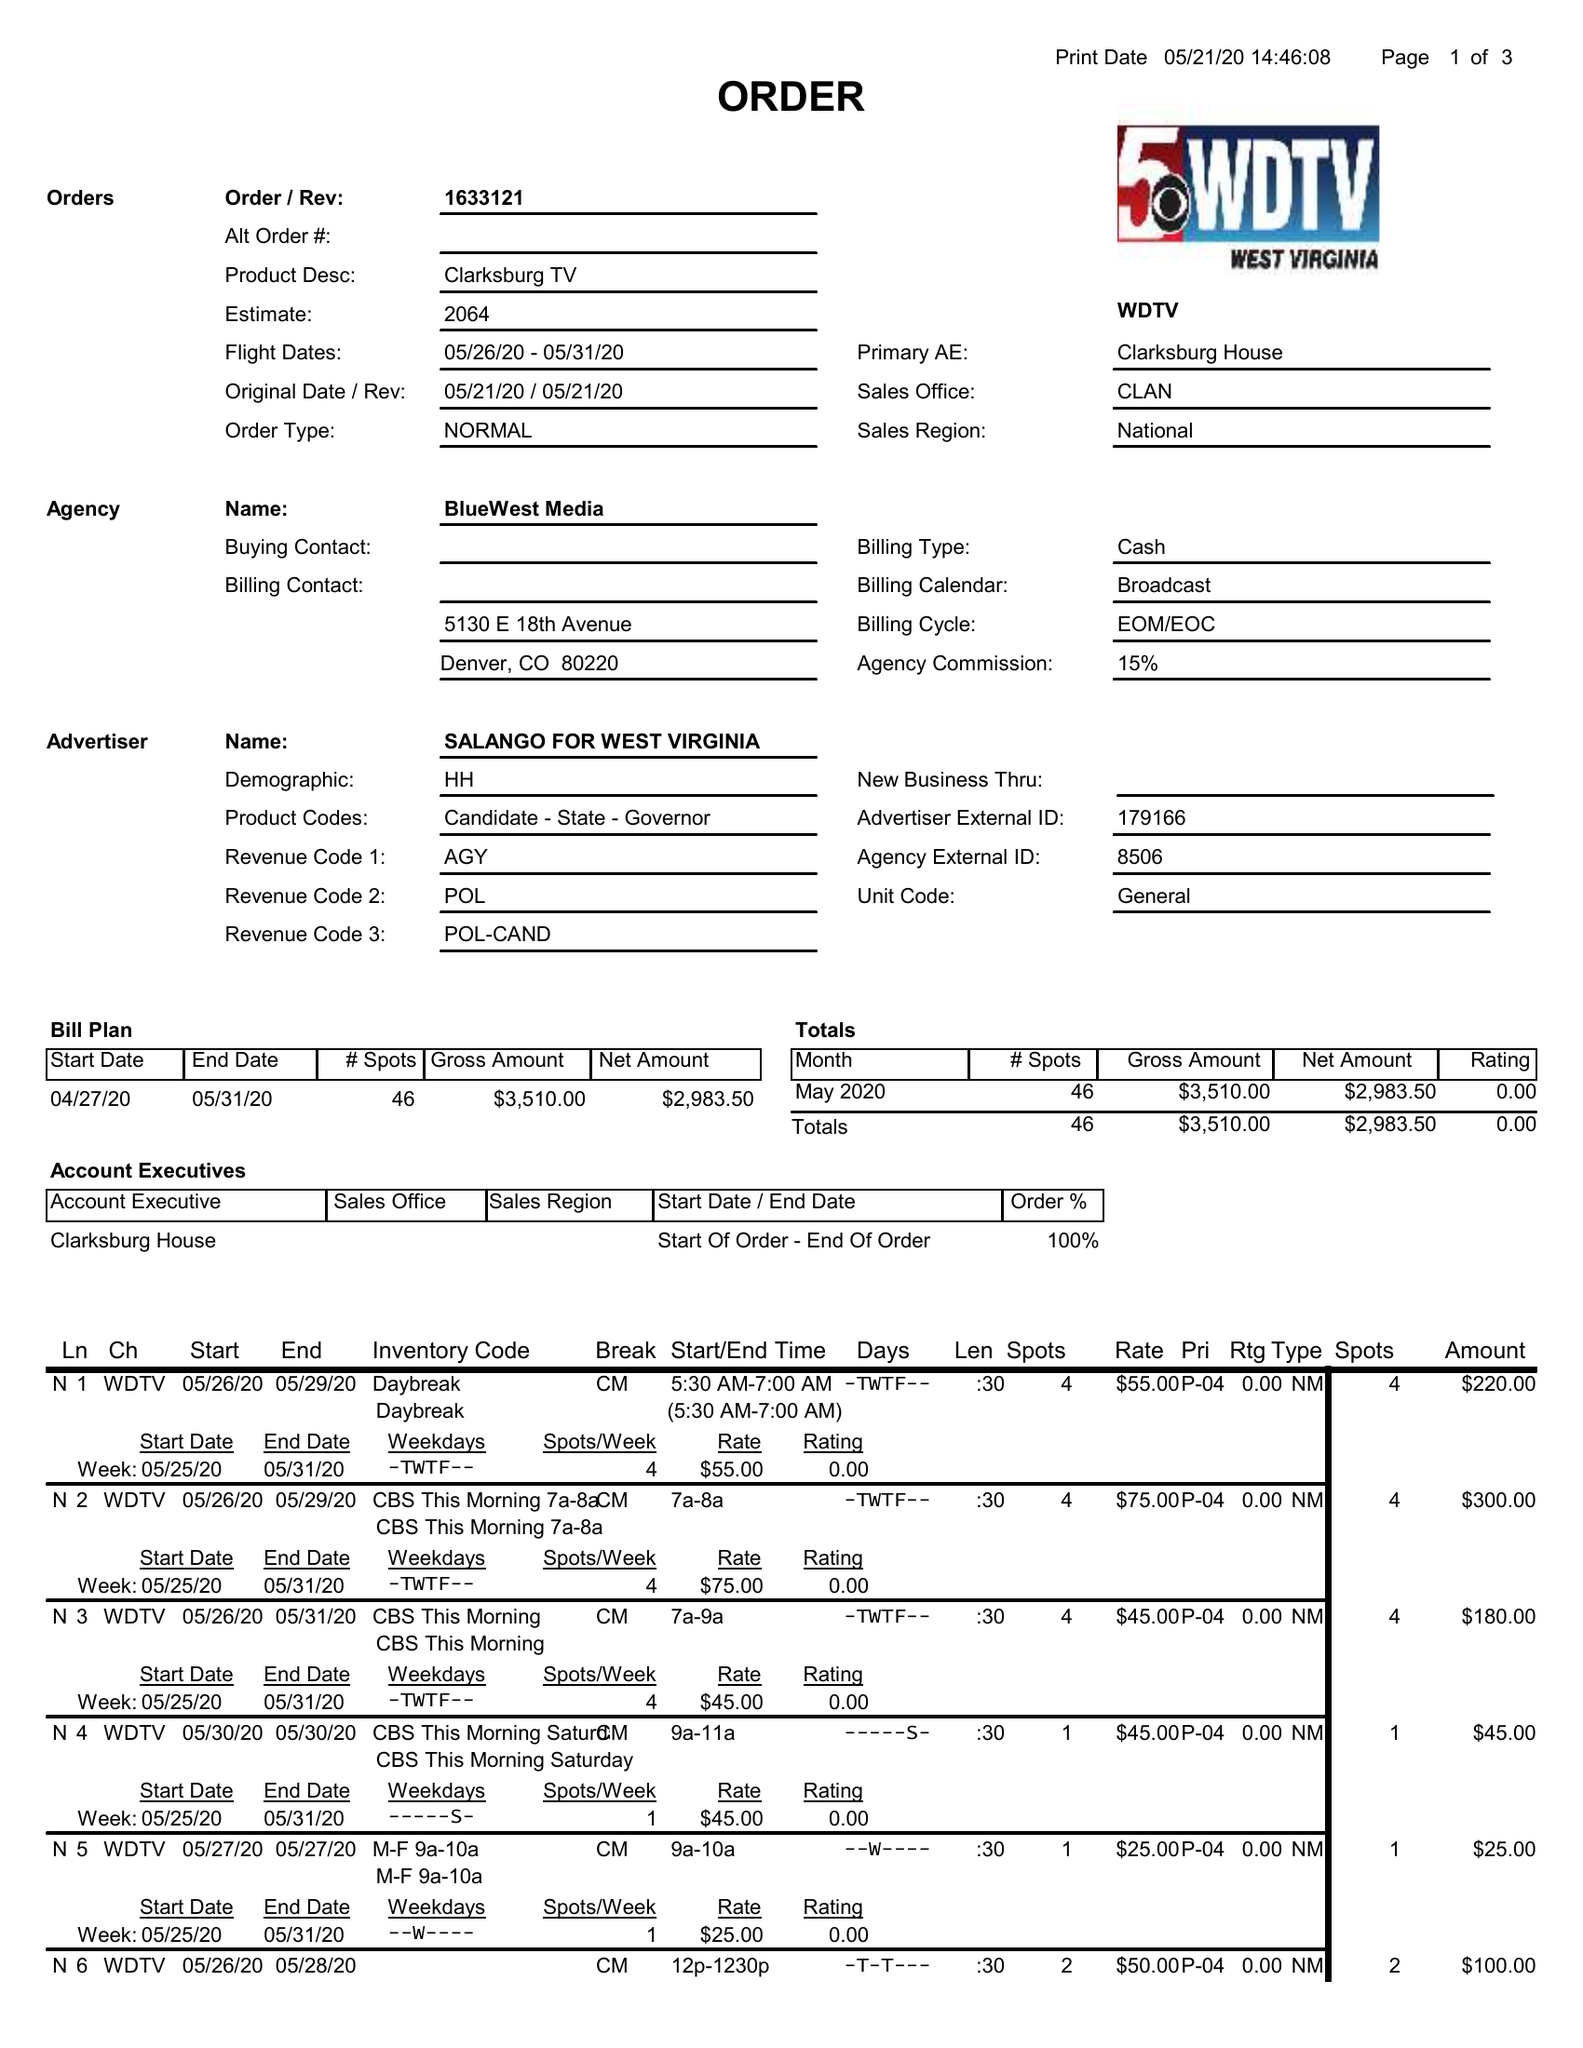What is the value for the flight_to?
Answer the question using a single word or phrase. 05/31/20 